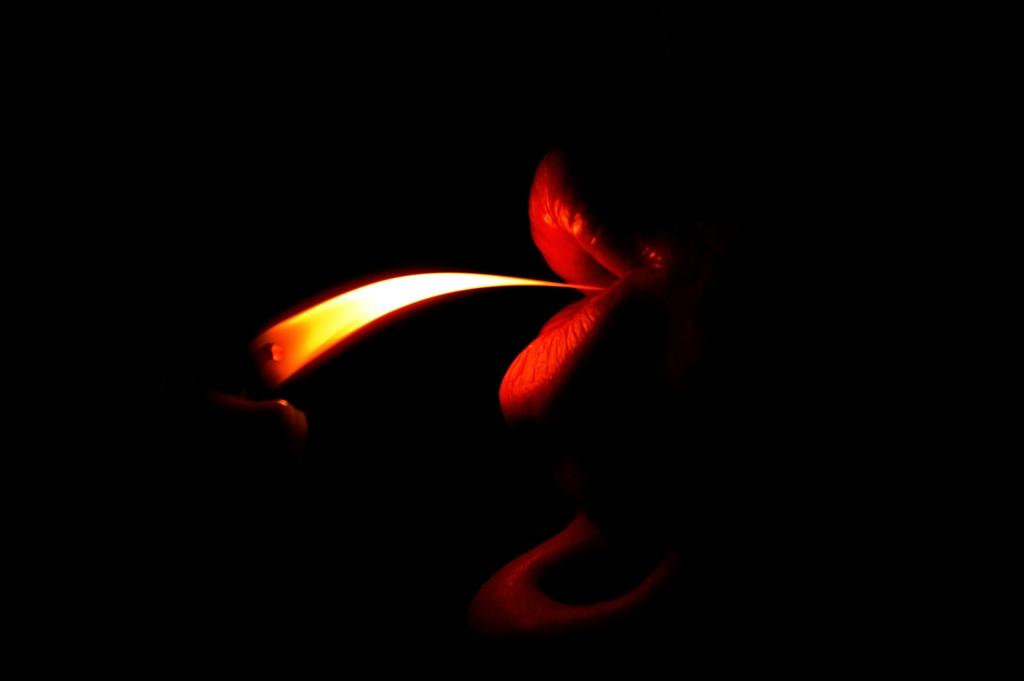What object can be seen in the image that produces light or heat? There is a candle in the image that produces light or heat. What is the primary source of fire in the image? There is a fire in the image. What object in the image resembles a lip? There is a lip-like thing in front of the fire. How does the kite fly in the image? There is no kite present in the image, so it cannot be flying. What direction is the head turning in the image? There is no head present in the image, so it cannot be turning. 